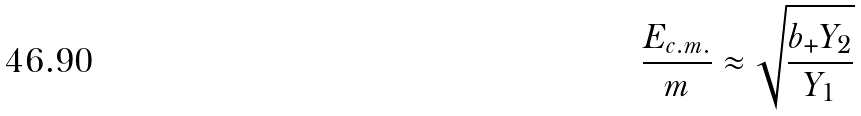Convert formula to latex. <formula><loc_0><loc_0><loc_500><loc_500>\frac { E _ { c . m . } } { m } \approx \sqrt { \frac { b _ { + } Y _ { 2 } } { Y _ { 1 } } }</formula> 